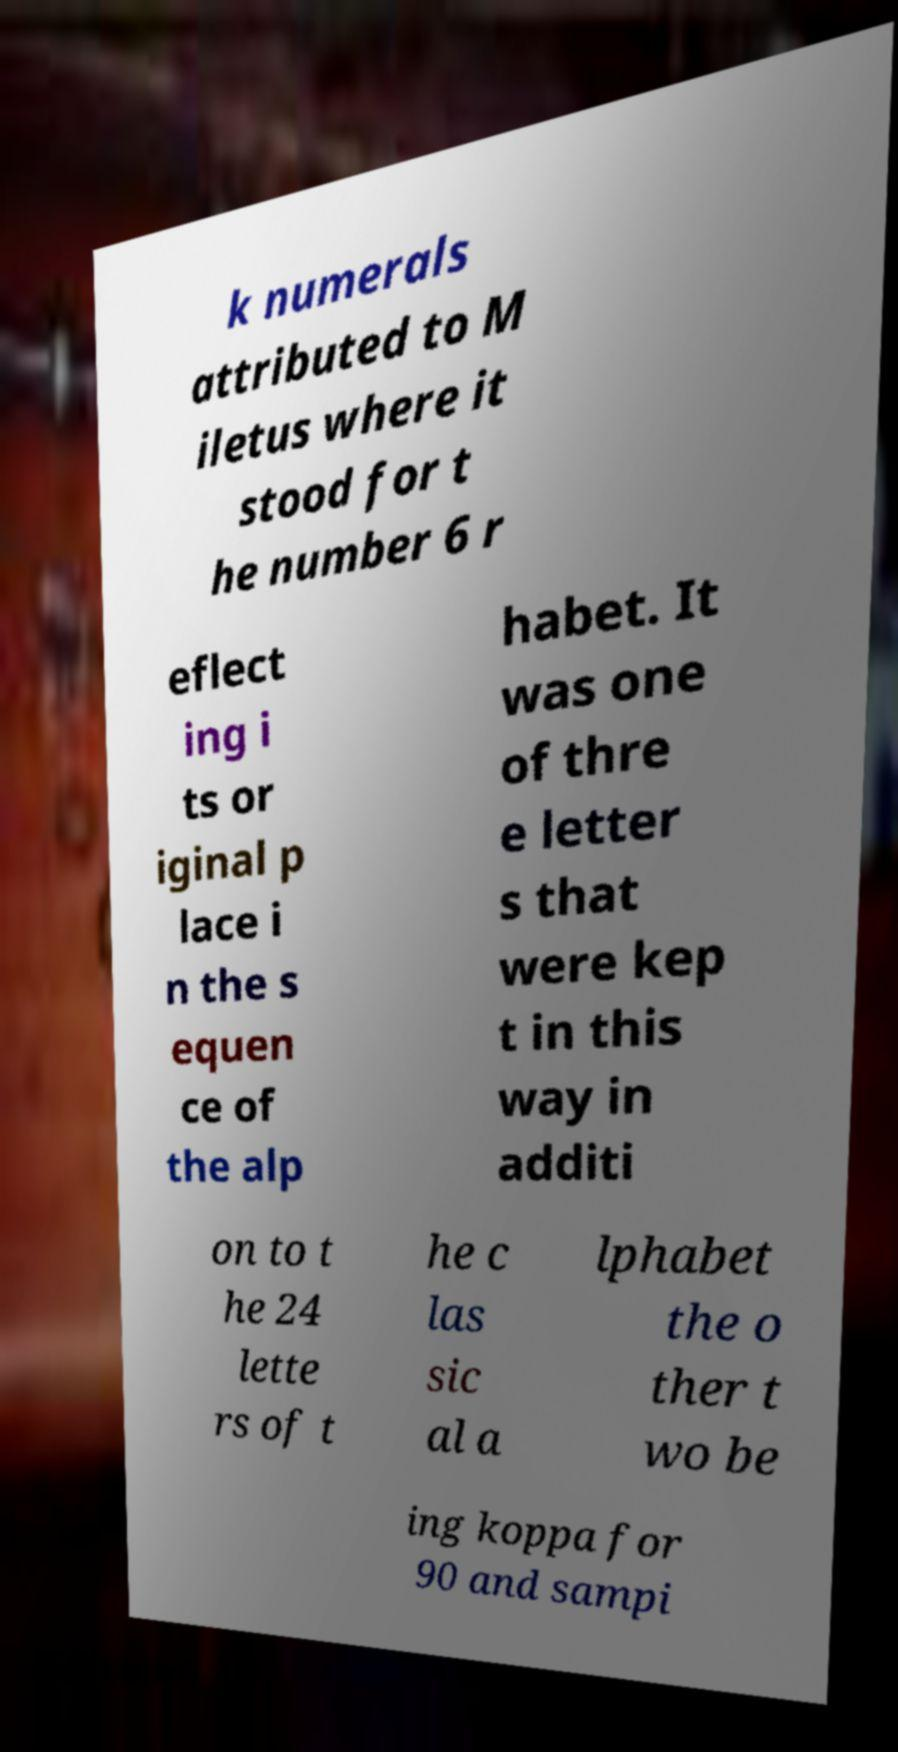Could you assist in decoding the text presented in this image and type it out clearly? k numerals attributed to M iletus where it stood for t he number 6 r eflect ing i ts or iginal p lace i n the s equen ce of the alp habet. It was one of thre e letter s that were kep t in this way in additi on to t he 24 lette rs of t he c las sic al a lphabet the o ther t wo be ing koppa for 90 and sampi 